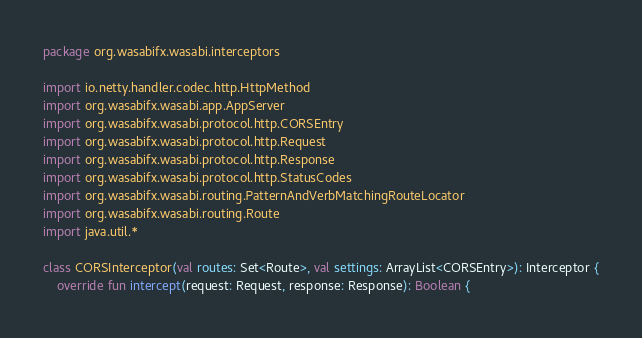Convert code to text. <code><loc_0><loc_0><loc_500><loc_500><_Kotlin_>package org.wasabifx.wasabi.interceptors

import io.netty.handler.codec.http.HttpMethod
import org.wasabifx.wasabi.app.AppServer
import org.wasabifx.wasabi.protocol.http.CORSEntry
import org.wasabifx.wasabi.protocol.http.Request
import org.wasabifx.wasabi.protocol.http.Response
import org.wasabifx.wasabi.protocol.http.StatusCodes
import org.wasabifx.wasabi.routing.PatternAndVerbMatchingRouteLocator
import org.wasabifx.wasabi.routing.Route
import java.util.*

class CORSInterceptor(val routes: Set<Route>, val settings: ArrayList<CORSEntry>): Interceptor {
    override fun intercept(request: Request, response: Response): Boolean {</code> 